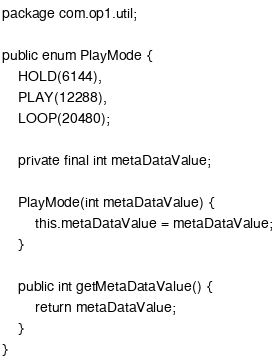Convert code to text. <code><loc_0><loc_0><loc_500><loc_500><_Java_>package com.op1.util;

public enum PlayMode {
    HOLD(6144),
    PLAY(12288),
    LOOP(20480);

    private final int metaDataValue;

    PlayMode(int metaDataValue) {
        this.metaDataValue = metaDataValue;
    }

    public int getMetaDataValue() {
        return metaDataValue;
    }
}
</code> 